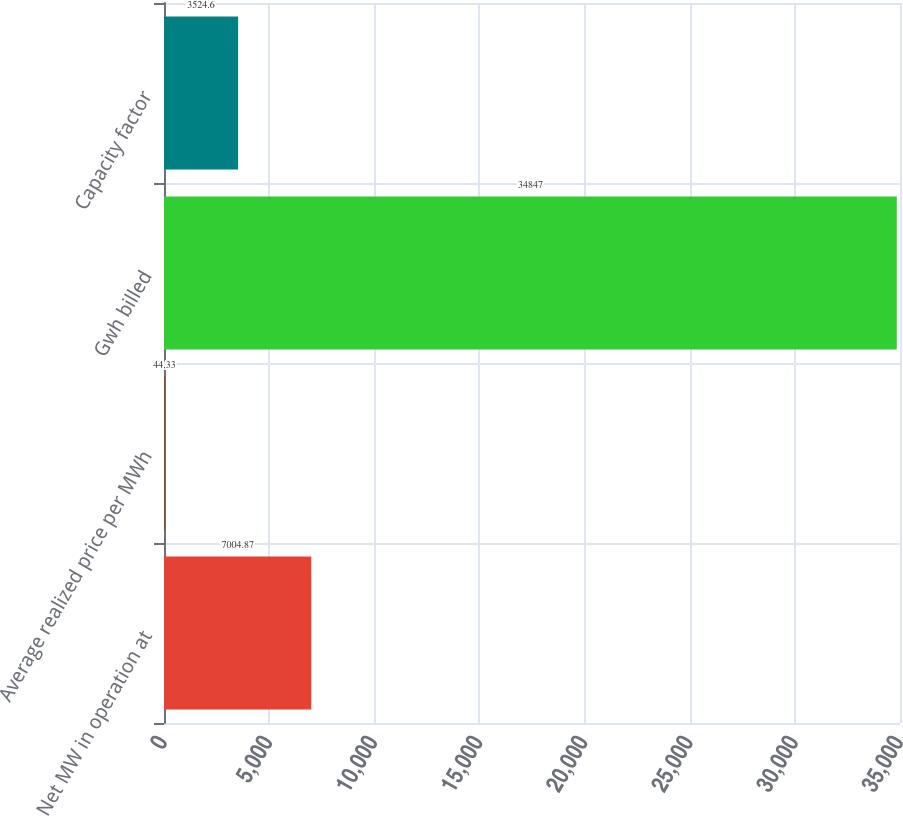<chart> <loc_0><loc_0><loc_500><loc_500><bar_chart><fcel>Net MW in operation at<fcel>Average realized price per MWh<fcel>Gwh billed<fcel>Capacity factor<nl><fcel>7004.87<fcel>44.33<fcel>34847<fcel>3524.6<nl></chart> 